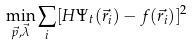<formula> <loc_0><loc_0><loc_500><loc_500>\min _ { \vec { p } , \vec { \lambda } } \sum _ { i } [ H \Psi _ { t } ( \vec { r _ { i } } ) - f ( \vec { r _ { i } } ) ] ^ { 2 }</formula> 